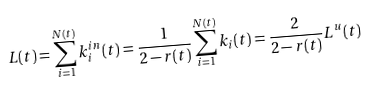<formula> <loc_0><loc_0><loc_500><loc_500>L ( t ) = \sum _ { i = 1 } ^ { N ( t ) } k ^ { i n } _ { i } ( t ) = \frac { 1 } { 2 - r ( t ) } \sum _ { i = 1 } ^ { N ( t ) } { k _ { i } ( t ) } = \frac { 2 } { 2 - r ( t ) } L ^ { u } ( t )</formula> 